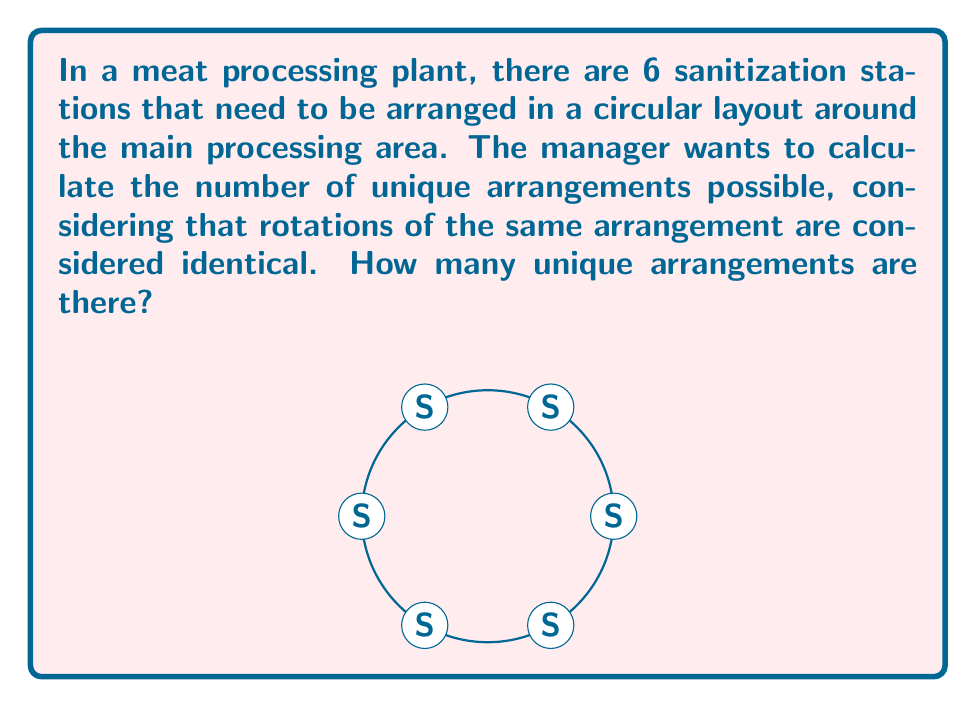Could you help me with this problem? Let's approach this step-by-step using concepts from ring theory:

1) First, we need to understand that this problem is equivalent to finding the number of distinct necklaces with 6 beads, where rotations are considered the same.

2) The total number of permutations of 6 objects is 6! = 720.

3) However, in a circular arrangement, rotations of the same arrangement are considered identical. There are 6 possible rotations for each arrangement (including the original arrangement).

4) In ring theory, this is equivalent to finding the number of orbits under the action of the cyclic group $C_6$ on the set of all permutations.

5) We can use Burnside's lemma to solve this. Let X be the set of all permutations and G be the cyclic group $C_6$. Burnside's lemma states:

   $$|X/G| = \frac{1}{|G|} \sum_{g \in G} |X^g|$$

   where $|X/G|$ is the number of orbits (unique arrangements), $|G|$ is the order of the group (6 in this case), and $|X^g|$ is the number of elements fixed by each group element g.

6) For the identity element, all 720 permutations are fixed.
   For rotations by 1/6, 1/3, and 1/2 of the circle, no permutations are fixed.
   For rotations by 2/3 and 5/6 of the circle, only arrangements with a period of 2 are fixed (6 such arrangements).

7) Applying Burnside's lemma:

   $$|X/G| = \frac{1}{6}(720 + 0 + 0 + 0 + 6 + 6) = \frac{732}{6} = 122$$

Therefore, there are 122 unique arrangements of the sanitization stations.
Answer: 122 